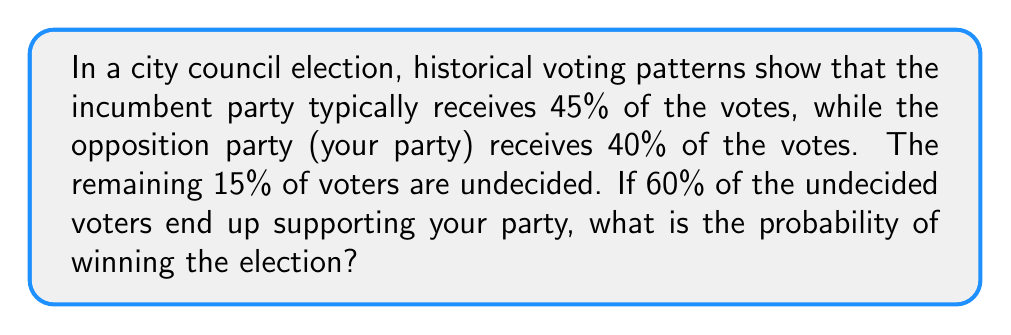Can you answer this question? Let's approach this step-by-step:

1) First, let's define our variables:
   $I$ = Incumbent party's vote share
   $O$ = Opposition party's initial vote share
   $U$ = Undecided voters
   $p$ = Proportion of undecided voters supporting the opposition

2) Given information:
   $I = 45\%$
   $O = 40\%$
   $U = 15\%$
   $p = 60\% = 0.6$

3) To win, the opposition needs to gain enough votes from the undecided voters to surpass 50% of the total votes.

4) The additional votes the opposition will receive:
   $\text{Additional votes} = U \times p = 15\% \times 0.6 = 9\%$

5) Total opposition votes after undecided voters cast their ballots:
   $\text{Total opposition votes} = O + (U \times p) = 40\% + 9\% = 49\%$

6) Since 49% < 50%, the opposition does not win the election.

7) The probability of winning in this scenario is 0, as the opposition party does not reach the majority threshold even with the support from undecided voters.
Answer: 0 